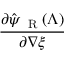<formula> <loc_0><loc_0><loc_500><loc_500>\frac { \partial \hat { \psi } _ { R } ( \Lambda ) } { \partial { \nabla \xi } }</formula> 